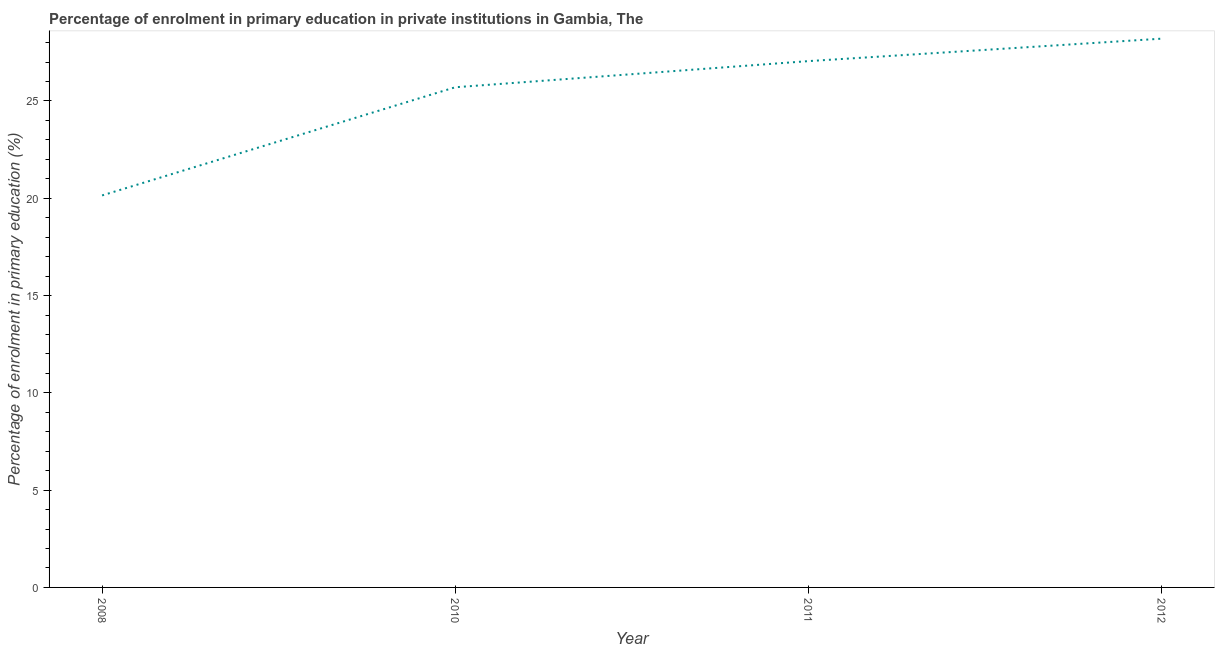What is the enrolment percentage in primary education in 2010?
Your answer should be very brief. 25.7. Across all years, what is the maximum enrolment percentage in primary education?
Give a very brief answer. 28.2. Across all years, what is the minimum enrolment percentage in primary education?
Provide a short and direct response. 20.15. What is the sum of the enrolment percentage in primary education?
Make the answer very short. 101.1. What is the difference between the enrolment percentage in primary education in 2010 and 2012?
Offer a terse response. -2.5. What is the average enrolment percentage in primary education per year?
Your answer should be very brief. 25.28. What is the median enrolment percentage in primary education?
Provide a short and direct response. 26.38. In how many years, is the enrolment percentage in primary education greater than 22 %?
Provide a succinct answer. 3. Do a majority of the years between 2011 and 2012 (inclusive) have enrolment percentage in primary education greater than 12 %?
Provide a succinct answer. Yes. What is the ratio of the enrolment percentage in primary education in 2011 to that in 2012?
Your response must be concise. 0.96. Is the difference between the enrolment percentage in primary education in 2008 and 2011 greater than the difference between any two years?
Your response must be concise. No. What is the difference between the highest and the second highest enrolment percentage in primary education?
Your answer should be compact. 1.15. Is the sum of the enrolment percentage in primary education in 2008 and 2010 greater than the maximum enrolment percentage in primary education across all years?
Give a very brief answer. Yes. What is the difference between the highest and the lowest enrolment percentage in primary education?
Give a very brief answer. 8.06. In how many years, is the enrolment percentage in primary education greater than the average enrolment percentage in primary education taken over all years?
Give a very brief answer. 3. What is the difference between two consecutive major ticks on the Y-axis?
Provide a succinct answer. 5. Are the values on the major ticks of Y-axis written in scientific E-notation?
Give a very brief answer. No. Does the graph contain any zero values?
Provide a succinct answer. No. What is the title of the graph?
Provide a succinct answer. Percentage of enrolment in primary education in private institutions in Gambia, The. What is the label or title of the X-axis?
Provide a succinct answer. Year. What is the label or title of the Y-axis?
Offer a terse response. Percentage of enrolment in primary education (%). What is the Percentage of enrolment in primary education (%) of 2008?
Your answer should be very brief. 20.15. What is the Percentage of enrolment in primary education (%) of 2010?
Ensure brevity in your answer.  25.7. What is the Percentage of enrolment in primary education (%) of 2011?
Ensure brevity in your answer.  27.05. What is the Percentage of enrolment in primary education (%) in 2012?
Make the answer very short. 28.2. What is the difference between the Percentage of enrolment in primary education (%) in 2008 and 2010?
Offer a terse response. -5.56. What is the difference between the Percentage of enrolment in primary education (%) in 2008 and 2011?
Ensure brevity in your answer.  -6.9. What is the difference between the Percentage of enrolment in primary education (%) in 2008 and 2012?
Ensure brevity in your answer.  -8.06. What is the difference between the Percentage of enrolment in primary education (%) in 2010 and 2011?
Provide a short and direct response. -1.34. What is the difference between the Percentage of enrolment in primary education (%) in 2010 and 2012?
Ensure brevity in your answer.  -2.5. What is the difference between the Percentage of enrolment in primary education (%) in 2011 and 2012?
Your response must be concise. -1.15. What is the ratio of the Percentage of enrolment in primary education (%) in 2008 to that in 2010?
Your answer should be very brief. 0.78. What is the ratio of the Percentage of enrolment in primary education (%) in 2008 to that in 2011?
Offer a very short reply. 0.74. What is the ratio of the Percentage of enrolment in primary education (%) in 2008 to that in 2012?
Keep it short and to the point. 0.71. What is the ratio of the Percentage of enrolment in primary education (%) in 2010 to that in 2012?
Give a very brief answer. 0.91. 